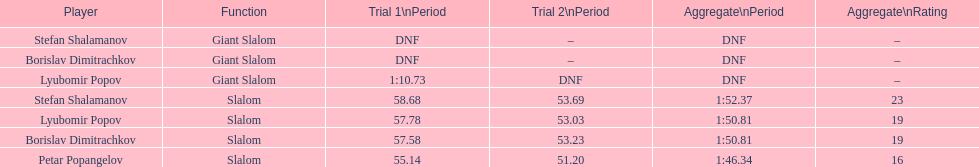How long did it take for lyubomir popov to finish the giant slalom in race 1? 1:10.73. 